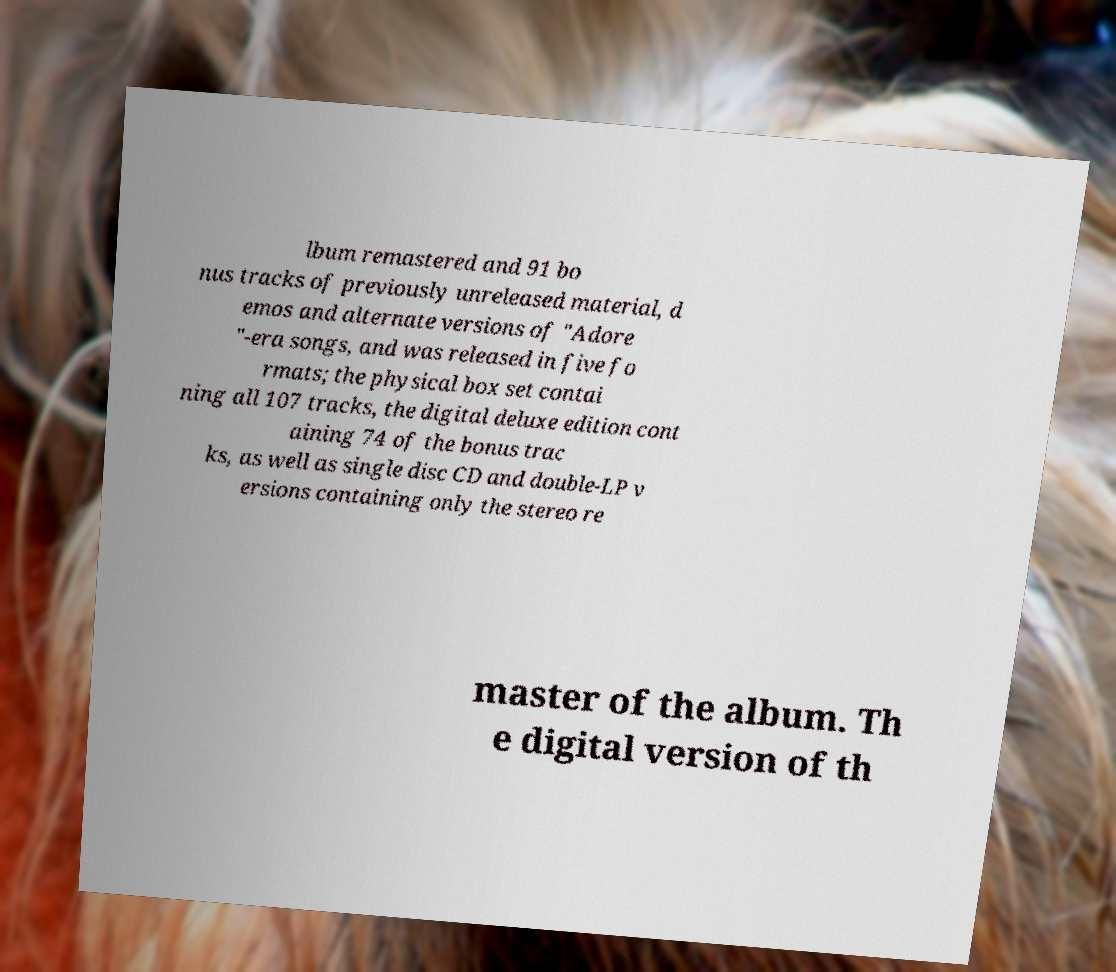What messages or text are displayed in this image? I need them in a readable, typed format. lbum remastered and 91 bo nus tracks of previously unreleased material, d emos and alternate versions of "Adore "-era songs, and was released in five fo rmats; the physical box set contai ning all 107 tracks, the digital deluxe edition cont aining 74 of the bonus trac ks, as well as single disc CD and double-LP v ersions containing only the stereo re master of the album. Th e digital version of th 